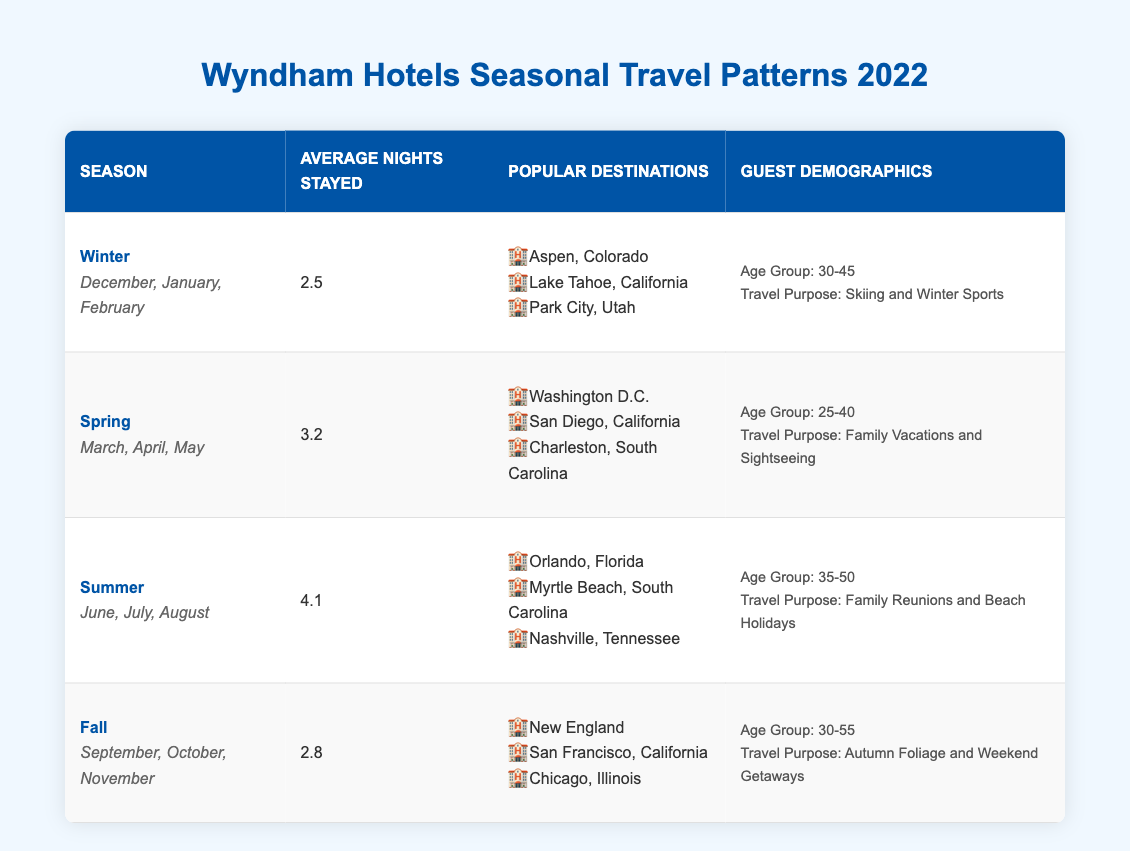What is the average number of nights stayed by guests during the Summer season? Looking at the table, the average number of nights stayed in the Summer season (June, July, August) is explicitly listed as 4.1.
Answer: 4.1 Which travel purpose is most common among Winter guests? The table indicates that the travel purpose for Winter guests (ages 30-45) is skiing and winter sports, as stated in the guest demographics.
Answer: Skiing and Winter Sports How many popular destinations are listed for the Spring season? The table shows that there are three popular destinations mentioned for the Spring season (Washington D.C., San Diego, Charleston).
Answer: 3 What is the age range of guests traveling for Autumn Foliage? According to the table, the age group for guests traveling during the Fall season is 30-55 years old, as stated in the demographics section.
Answer: 30-55 How does the average number of nights stayed in Fall compare to Winter? From the table, the average nights stayed in Fall is 2.8, while in Winter, it is 2.5. So, Fall has an average of 0.3 nights more than Winter (2.8 - 2.5 = 0.3).
Answer: Fall has 0.3 more nights What is the total average nights stayed across all seasons? Summing the average nights stayed for each season: Winter (2.5) + Spring (3.2) + Summer (4.1) + Fall (2.8) equals 12.6. Dividing that by the number of seasons (4) gives an average of 3.15 (12.6 / 4 = 3.15).
Answer: 3.15 Is there a season when guests stay more than 4 nights on average? The table indicates that the average nights stayed in Summer is 4.1, meaning it is indeed the only season where guests stay more than 4 nights on average.
Answer: Yes Which season has the oldest average guest age demographics? The chart shows that the Fall season has demographics for ages 30-55, while the Summer has 35-50. Therefore, Fall encompasses the eldest average age group among the seasons.
Answer: Fall How many popular destinations do guests visit for Summer reunions compared to Winter sports? Guests traveling in the Summer visit three popular destinations (Orlando, Myrtle Beach, Nashville) and Winter guests visit three (Aspen, Lake Tahoe, Park City). Thus, both seasons have an equal number of popular destinations.
Answer: Equal (3 each) If a guest travels in Spring, what is their maximum age based on demographics? The table specifies that the age group for guests traveling during Spring is 25-40, meaning 40 years old is the maximum age in this demographic.
Answer: 40 What travel purpose do most guests have in the Summer, and how does it differ from Winter's purpose? The table indicates that Summer guests are traveling for family reunions and beach holidays, while Winter guests are going for skiing and winter sports. Hence, the focus shifts from family-centric activities in Summer to sports-based in Winter.
Answer: Family Reunions (Summer) vs. Skiing (Winter) 